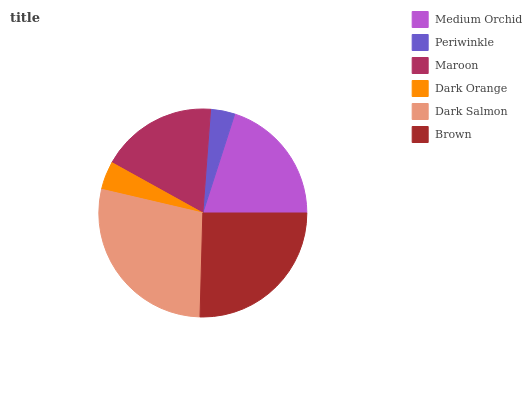Is Periwinkle the minimum?
Answer yes or no. Yes. Is Dark Salmon the maximum?
Answer yes or no. Yes. Is Maroon the minimum?
Answer yes or no. No. Is Maroon the maximum?
Answer yes or no. No. Is Maroon greater than Periwinkle?
Answer yes or no. Yes. Is Periwinkle less than Maroon?
Answer yes or no. Yes. Is Periwinkle greater than Maroon?
Answer yes or no. No. Is Maroon less than Periwinkle?
Answer yes or no. No. Is Medium Orchid the high median?
Answer yes or no. Yes. Is Maroon the low median?
Answer yes or no. Yes. Is Brown the high median?
Answer yes or no. No. Is Dark Salmon the low median?
Answer yes or no. No. 